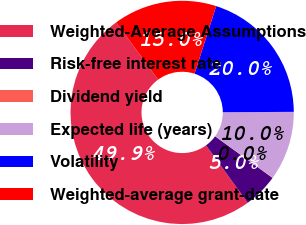Convert chart to OTSL. <chart><loc_0><loc_0><loc_500><loc_500><pie_chart><fcel>Weighted-Average Assumptions<fcel>Risk-free interest rate<fcel>Dividend yield<fcel>Expected life (years)<fcel>Volatility<fcel>Weighted-average grant-date<nl><fcel>49.92%<fcel>5.03%<fcel>0.04%<fcel>10.02%<fcel>19.99%<fcel>15.0%<nl></chart> 